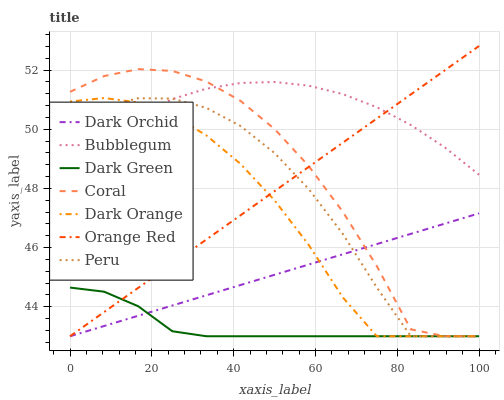Does Dark Green have the minimum area under the curve?
Answer yes or no. Yes. Does Bubblegum have the maximum area under the curve?
Answer yes or no. Yes. Does Coral have the minimum area under the curve?
Answer yes or no. No. Does Coral have the maximum area under the curve?
Answer yes or no. No. Is Dark Orchid the smoothest?
Answer yes or no. Yes. Is Coral the roughest?
Answer yes or no. Yes. Is Bubblegum the smoothest?
Answer yes or no. No. Is Bubblegum the roughest?
Answer yes or no. No. Does Dark Orange have the lowest value?
Answer yes or no. Yes. Does Bubblegum have the lowest value?
Answer yes or no. No. Does Orange Red have the highest value?
Answer yes or no. Yes. Does Coral have the highest value?
Answer yes or no. No. Is Dark Orchid less than Bubblegum?
Answer yes or no. Yes. Is Bubblegum greater than Dark Green?
Answer yes or no. Yes. Does Orange Red intersect Dark Orange?
Answer yes or no. Yes. Is Orange Red less than Dark Orange?
Answer yes or no. No. Is Orange Red greater than Dark Orange?
Answer yes or no. No. Does Dark Orchid intersect Bubblegum?
Answer yes or no. No. 